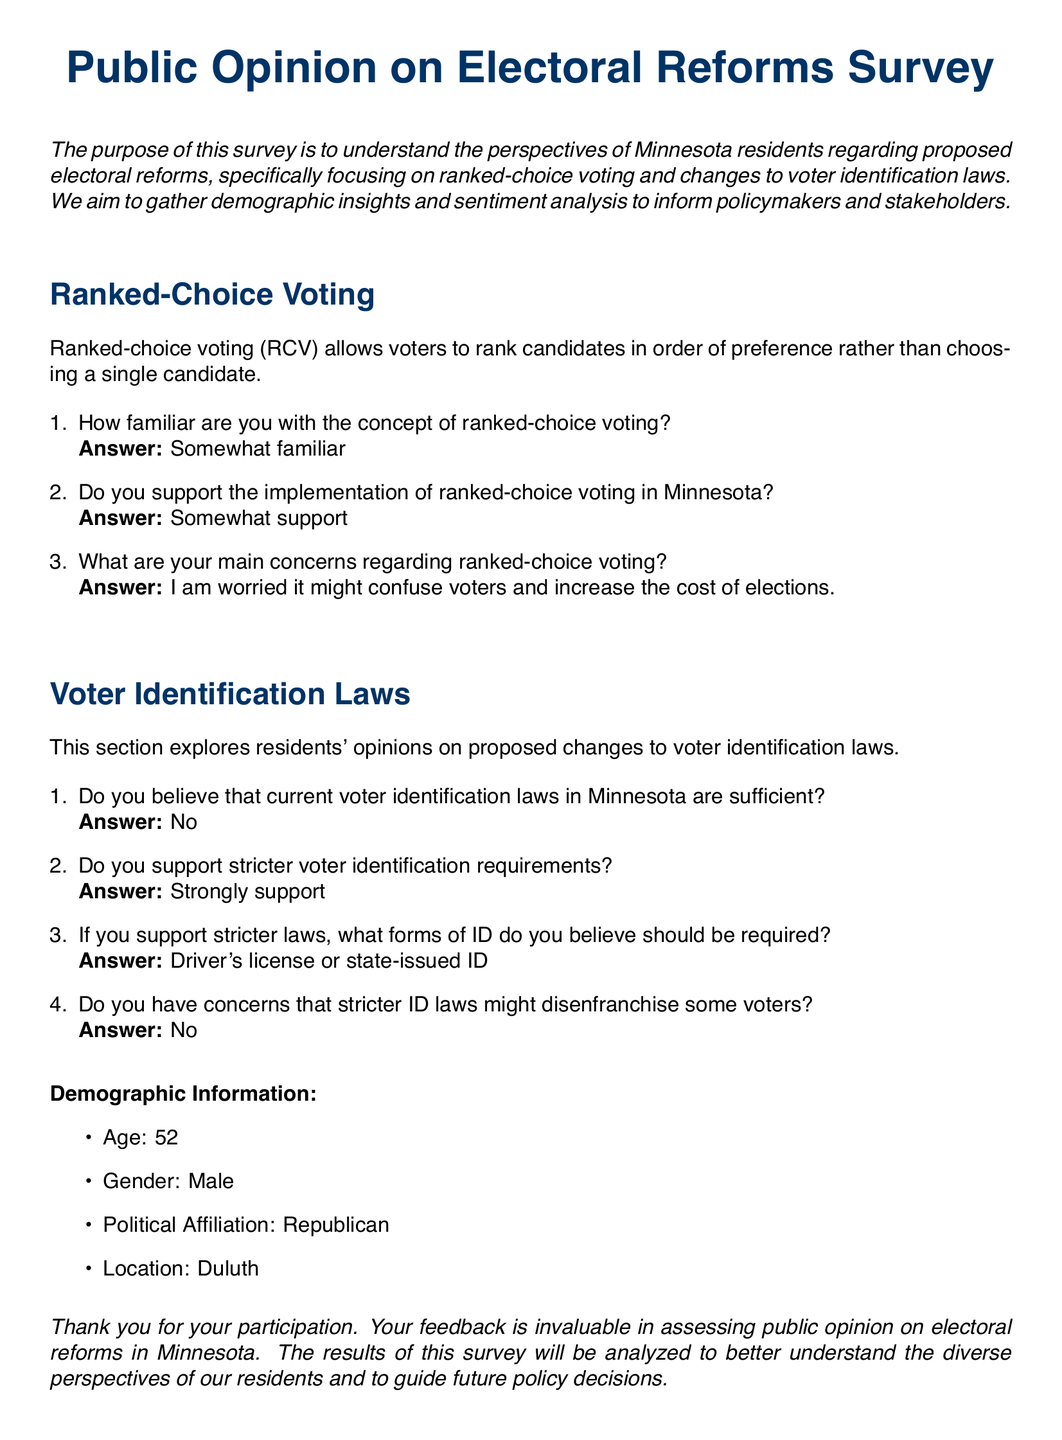How familiar are residents with ranked-choice voting? The survey explicitly asks participants about their familiarity with ranked-choice voting, and one response indicates being "Somewhat familiar."
Answer: Somewhat familiar What is the demographic age of the respondent? The document includes a section for demographic information that specifies the respondent's age.
Answer: 52 What form of ID does the respondent believe should be required? The survey asks about opinions on required forms of identification, and the answer includes "Driver's license or state-issued ID."
Answer: Driver's license or state-issued ID Do they support ranked-choice voting in Minnesota? The document reports on the level of support for ranked-choice voting in the survey responses.
Answer: Somewhat support What is the location of the respondent? The demographic section reveals where the participant is from.
Answer: Duluth What is the respondent's political affiliation? The document specifies the political affiliation of the participant in the demographic information.
Answer: Republican What are the main concerns regarding ranked-choice voting? The survey captures concerns related to ranked-choice voting, and a specific concern expressed is about confusion and costs.
Answer: I am worried it might confuse voters and increase the cost of elections Do they support stricter voter identification requirements? The survey questions participants on support for stricter identification laws and records that the participant "Strongly support" stricter requirements.
Answer: Strongly support Are concerns regarding disenfranchisement noted in the survey? The document contains a question regarding potential disenfranchisement due to stricter ID laws, and the response indicates there are no concerns.
Answer: No 